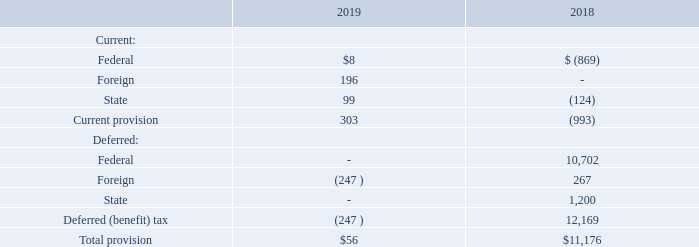13. Income Taxes
On December 22, 2017, the legislation commonly known as the Tax Cuts and Jobs Act (the “TCJA” or the “Act”) was enacted into law. The Act made comprehensive changes to the U.S. tax code, including, but not limited to: (1) reducing the U.S. federal corporate tax rate from 35% to 21%; (2) changing rules related to uses and limitations of net operating loss carry-forwards created in tax years beginning after December 31, 2017 as well as the repeal of the current carryback provisions for net operating losses arising in tax years ending after December 31, 2017; (3) immediate full expensing of certain qualified property; (4) creating a new limitation on deductible interest expense; (5) eliminating the corporate alternative minimum tax; (6) repeal of the deduction for income attributable to domestic production activities; and (7) changes in the manner in which international operations are taxed in the U.S. including a mandatory one- time transition tax on the accumulated untaxed earnings of foreign subsidiaries of U.S. shareholders.
In response to the TCJA, the U.S. Securities and Exchange Commission (“SEC”) staff issued Staff Accounting Bulletin No. 118 (“SAB 118”), which provides guidance on accounting for the tax effects of TCJA. The purpose of SAB 118 was to address any uncertainty or diversity of view in applying ASC Topic 740, Income Taxes in the reporting period in which the TCJA was enacted. SAB 118 addresses situations where the accounting is incomplete for certain income tax effects of the TJCA upon issuance of a company’s financial statements for the reporting period which include the enactment date. SAB 118 allows for a provisional amount to be recorded if it is a reasonable estimate of the impact of the TCJA. Additionally, SAB 118 allows for a measurement period to finalize the impacts of the TCJA, not to extend beyond one year from the date of enactment. For the year ended April 30, 2018, the Company recorded a provisional decrease in its deferred tax assets and liabilities for the reduction in the federal tax rate with a corresponding adjustment to the valuation allowance. During the year ended April 30, 2019, the Company completed the accounting for the tax effects of the TCJA with no material changes to the provisional estimate recorded in prior periods.
The TCJA also established the Global Intangible Low-Taxed Income (“GILTI”) provisions that impose a tax on foreign income in excess of a deemed return on tangible assets on foreign corporations. The Company does not anticipate being subject to GILTI due to the sale of Gillam in Fiscal 2018 and the treatment of FEI-Asia as a disregarded entity for U.S. tax purposes.
The provision for income taxes consisted of the following (in thousands):
When was the Tax Cuts and Jobs Act enacted into law? December 22, 2017. What is the total current provision for 2019 and 2018 respectively?
Answer scale should be: thousand. 303, (993). What is the total provision for 2019 and 2018 respectively?
Answer scale should be: thousand. $56, $11,176. What is the change in total provision between 2018 and 2019?
Answer scale should be: thousand. 56-11,176
Answer: -11120. What is the average current provision for 2018 and 2019?
Answer scale should be: thousand. (303+(993))/2
Answer: -345. In 2019, what is the percentage constitution of the current provision for foreign taxes among the total current provision?
Answer scale should be: percent. 196/303
Answer: 64.69. 